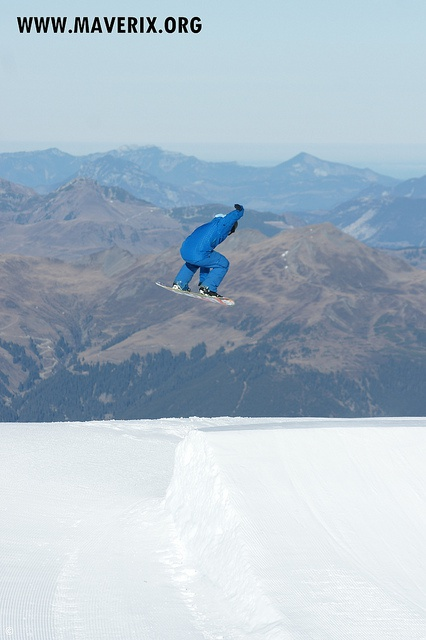Describe the objects in this image and their specific colors. I can see people in lightblue, blue, gray, and navy tones and snowboard in lightblue, darkgray, gray, and lightgray tones in this image. 